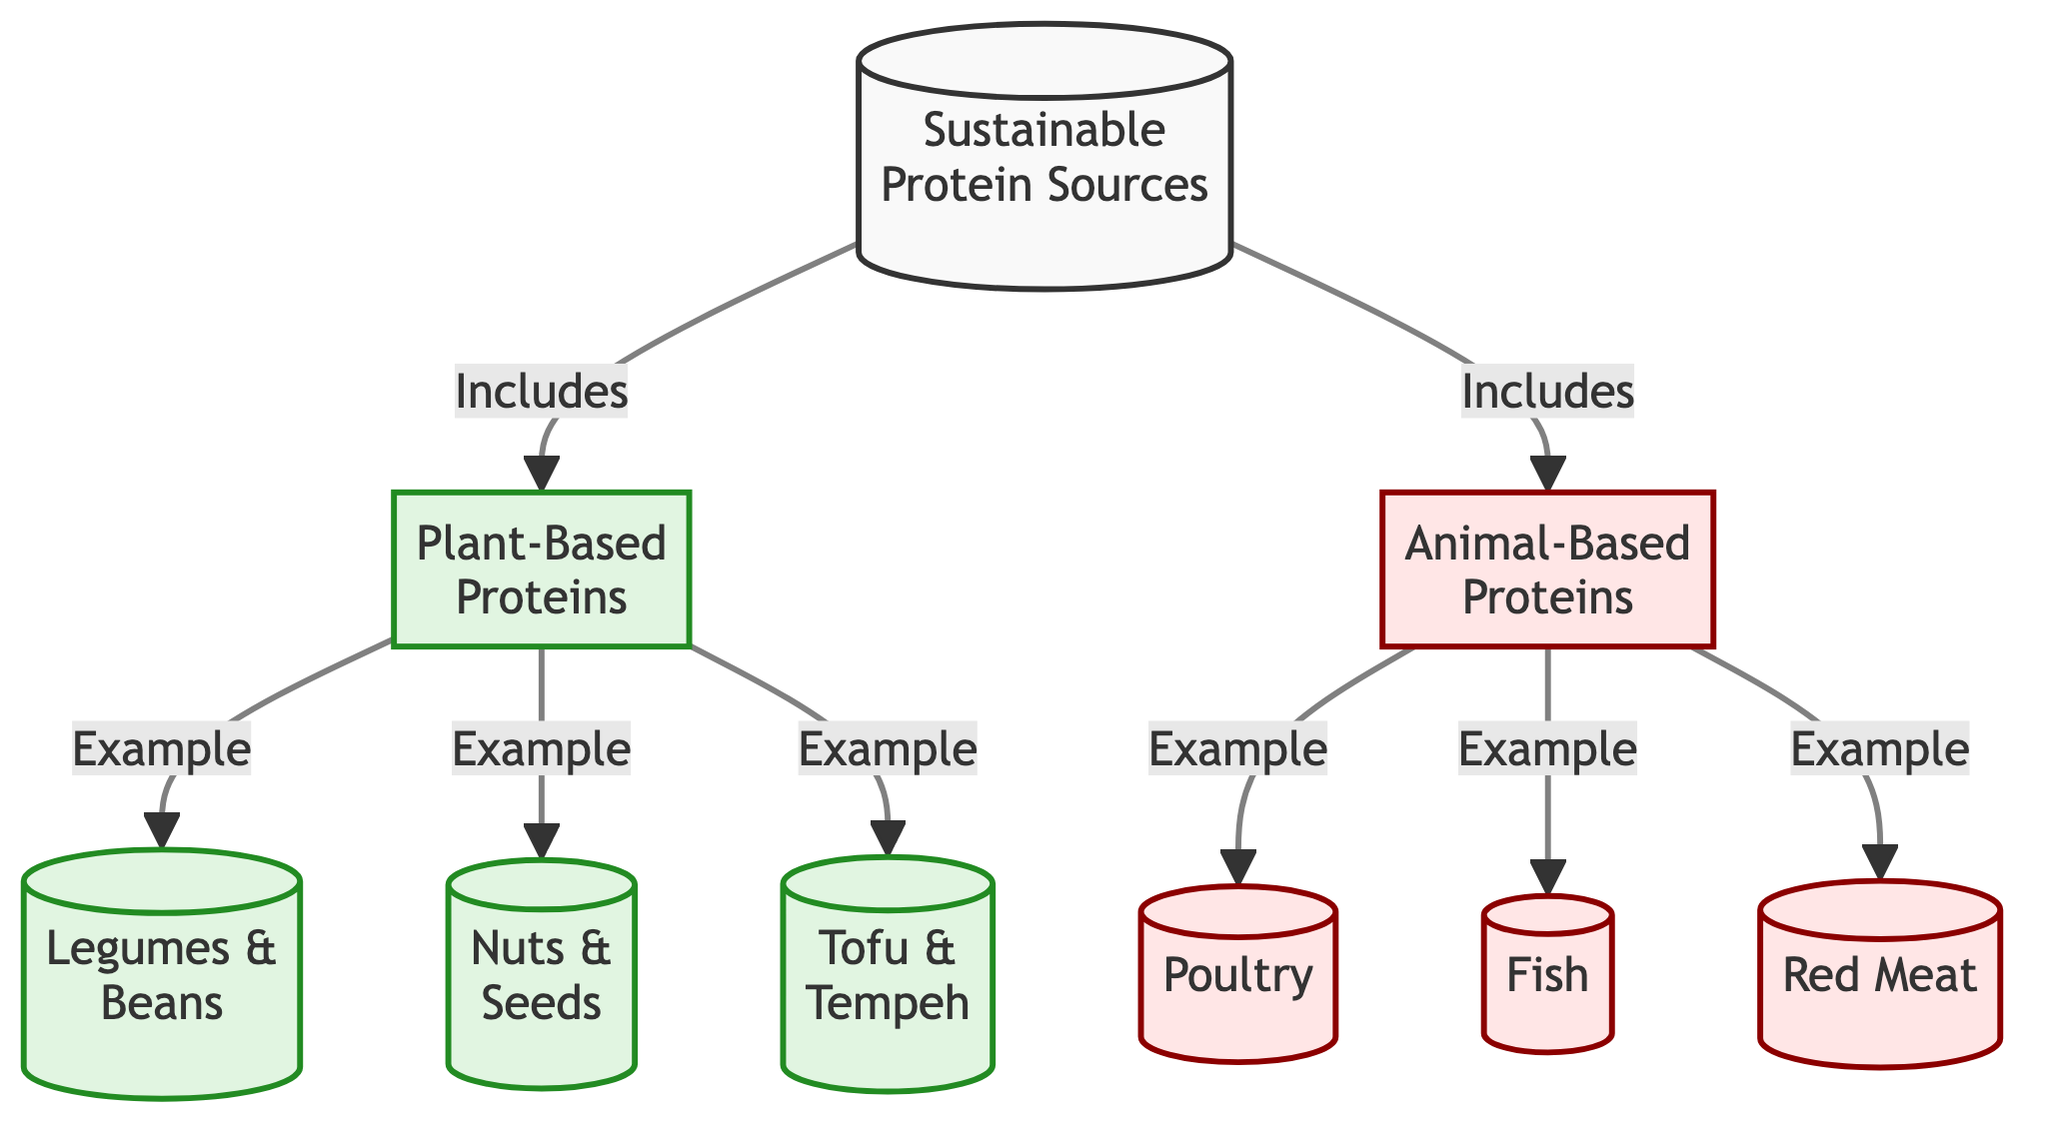What are the two main categories of sustainable protein sources? The diagram directly lists two main categories of sustainable protein sources at the top, which are "Plant-Based Proteins" and "Animal-Based Proteins."
Answer: Plant-Based Proteins, Animal-Based Proteins How many examples are there under Plant-Based Proteins? The diagram outlines three examples specifically under Plant-Based Proteins, which are "Legumes & Beans," "Nuts & Seeds," and "Tofu & Tempeh."
Answer: 3 What includes "Poultry" in the diagram? "Poultry" is included under the node "Animal-Based Proteins," showing its classification in the food chain structure.
Answer: Animal-Based Proteins Is "Fish" a plant-based protein source? The diagram places "Fish" under the "Animal-Based Proteins" category, indicating it is not a plant-based protein source.
Answer: No Which food source is linked to both categories in the diagram? The diagram does not show any food source that links between "Plant-Based Proteins" and "Animal-Based Proteins." Each category remains distinct and does not overlap.
Answer: None What is the color assigned to the Plant-Based Proteins section? The color coding in the diagram assigns a greenish color to the Plant-Based Proteins section, differentiating it from the other category.
Answer: Green How many examples of Animal-Based Proteins are listed? Upon reviewing the diagram, there are three examples of Animal-Based Proteins listed, namely "Poultry," "Fish," and "Red Meat."
Answer: 3 Which type of protein source is associated with "Tofu & Tempeh"? "Tofu & Tempeh" is classified under the category of Plant-Based Proteins according to the diagram layout.
Answer: Plant-Based Proteins Which category contains "Red Meat"? The diagram indicates that "Red Meat" falls under the "Animal-Based Proteins" category, showing its classification in the food system.
Answer: Animal-Based Proteins 